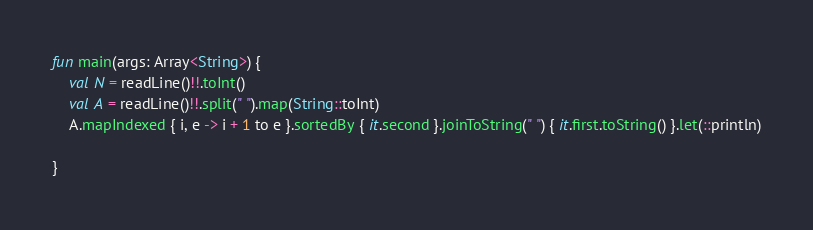<code> <loc_0><loc_0><loc_500><loc_500><_Kotlin_>fun main(args: Array<String>) {
    val N = readLine()!!.toInt()
    val A = readLine()!!.split(" ").map(String::toInt)
    A.mapIndexed { i, e -> i + 1 to e }.sortedBy { it.second }.joinToString(" ") { it.first.toString() }.let(::println)

}</code> 